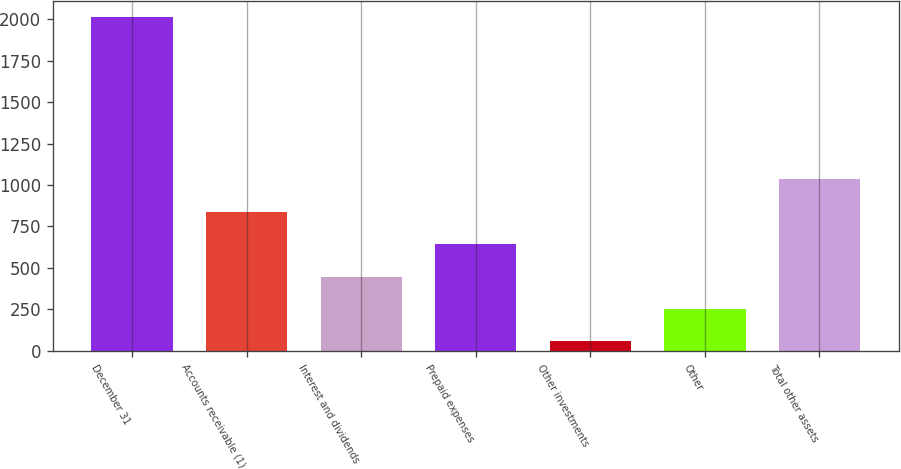Convert chart. <chart><loc_0><loc_0><loc_500><loc_500><bar_chart><fcel>December 31<fcel>Accounts receivable (1)<fcel>Interest and dividends<fcel>Prepaid expenses<fcel>Other investments<fcel>Other<fcel>Total other assets<nl><fcel>2011<fcel>838.6<fcel>447.8<fcel>643.2<fcel>57<fcel>252.4<fcel>1034<nl></chart> 